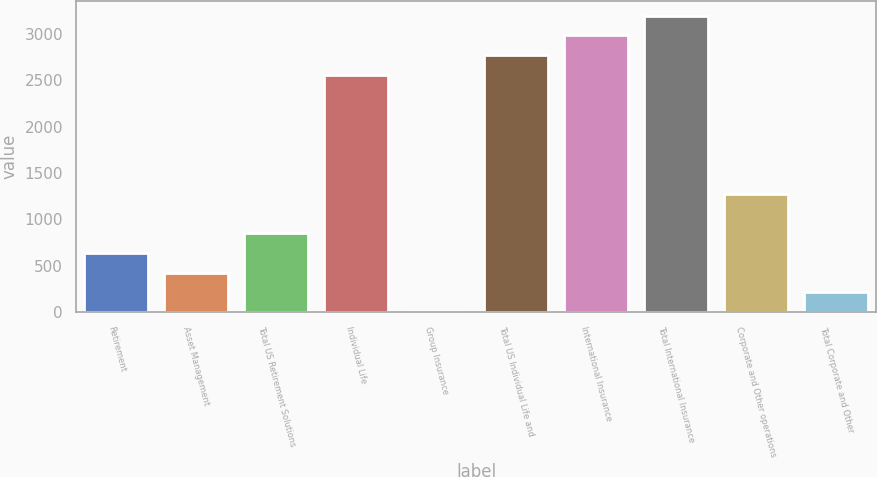Convert chart to OTSL. <chart><loc_0><loc_0><loc_500><loc_500><bar_chart><fcel>Retirement<fcel>Asset Management<fcel>Total US Retirement Solutions<fcel>Individual Life<fcel>Group Insurance<fcel>Total US Individual Life and<fcel>International Insurance<fcel>Total International Insurance<fcel>Corporate and Other operations<fcel>Total Corporate and Other<nl><fcel>639.31<fcel>426.35<fcel>852.27<fcel>2555.95<fcel>0.43<fcel>2768.91<fcel>2981.87<fcel>3194.83<fcel>1278.19<fcel>213.39<nl></chart> 